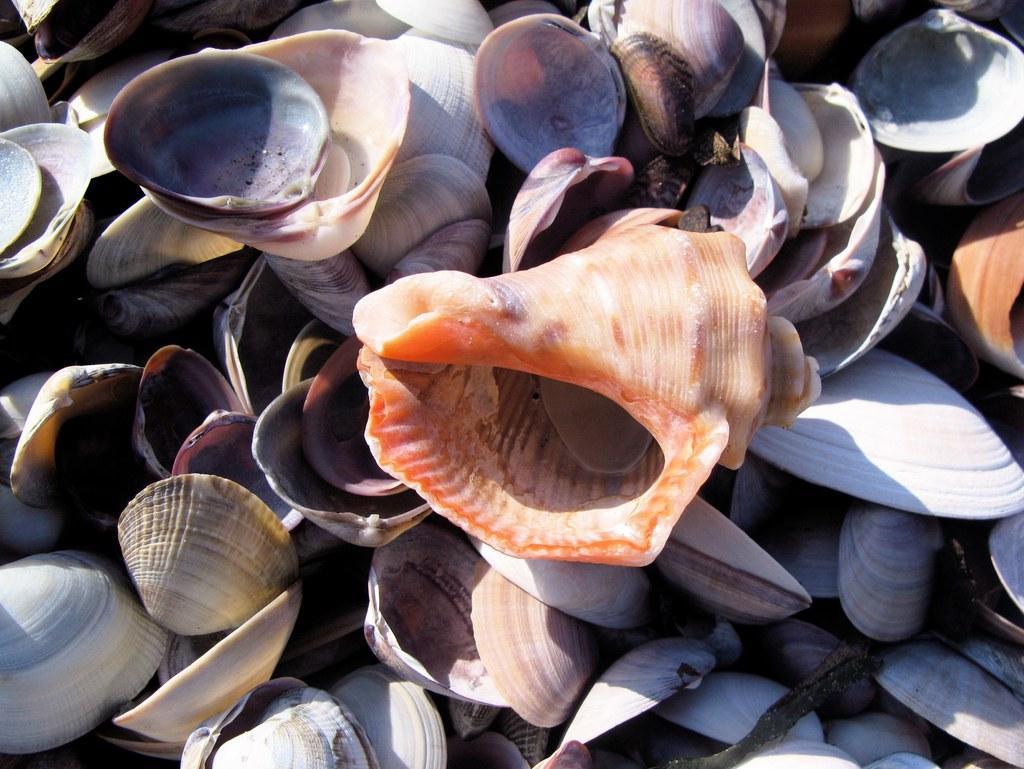Describe this image in one or two sentences. In this picture there are different types and different colors of shells. 